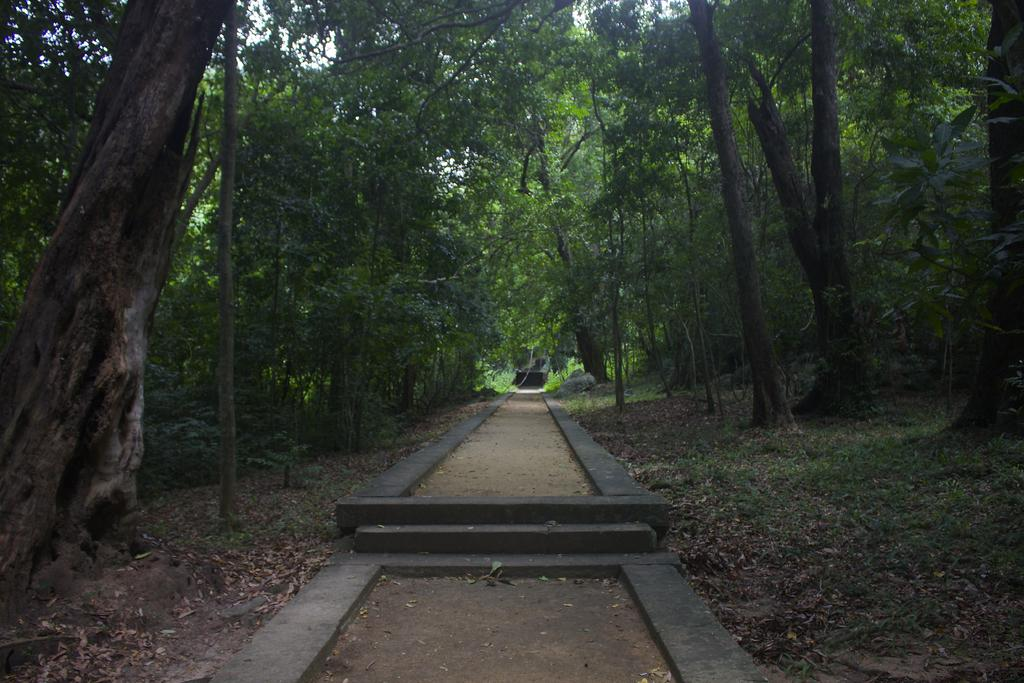What type of setting is depicted in the image? The image is an outside view. What can be seen at the bottom of the image? There is a path at the bottom of the image. What surrounds the path on both sides? There are many trees on both sides of the path. What covers the ground in the image? Grass is visible on the ground, and leaves are present on the ground. What type of list is being used to hammer an action in the image? There is no list, hammer, or action present in the image. 